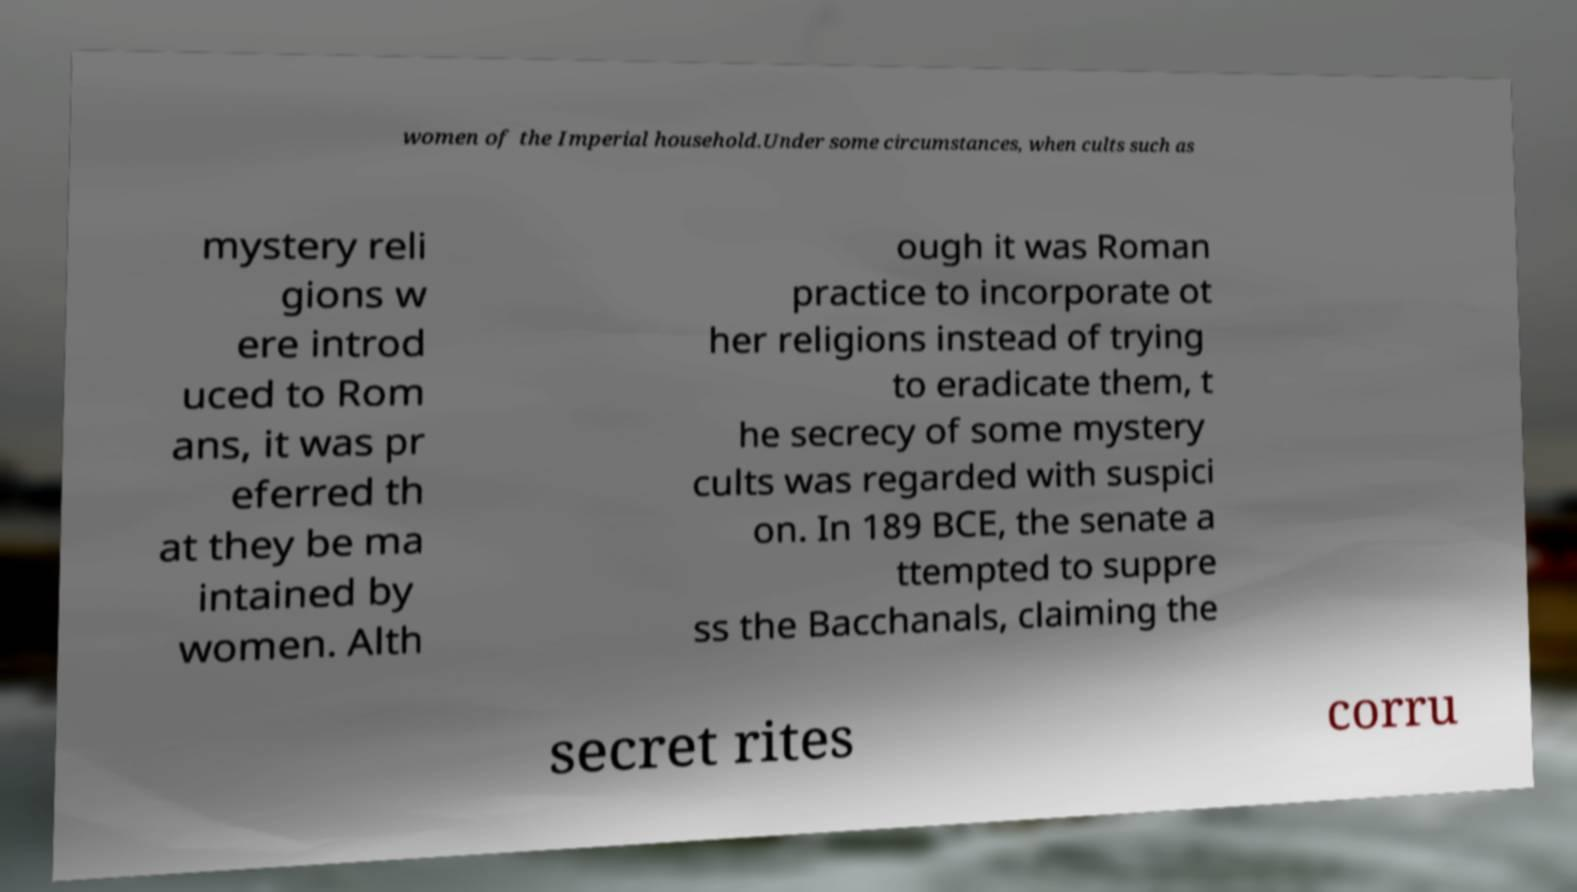For documentation purposes, I need the text within this image transcribed. Could you provide that? women of the Imperial household.Under some circumstances, when cults such as mystery reli gions w ere introd uced to Rom ans, it was pr eferred th at they be ma intained by women. Alth ough it was Roman practice to incorporate ot her religions instead of trying to eradicate them, t he secrecy of some mystery cults was regarded with suspici on. In 189 BCE, the senate a ttempted to suppre ss the Bacchanals, claiming the secret rites corru 